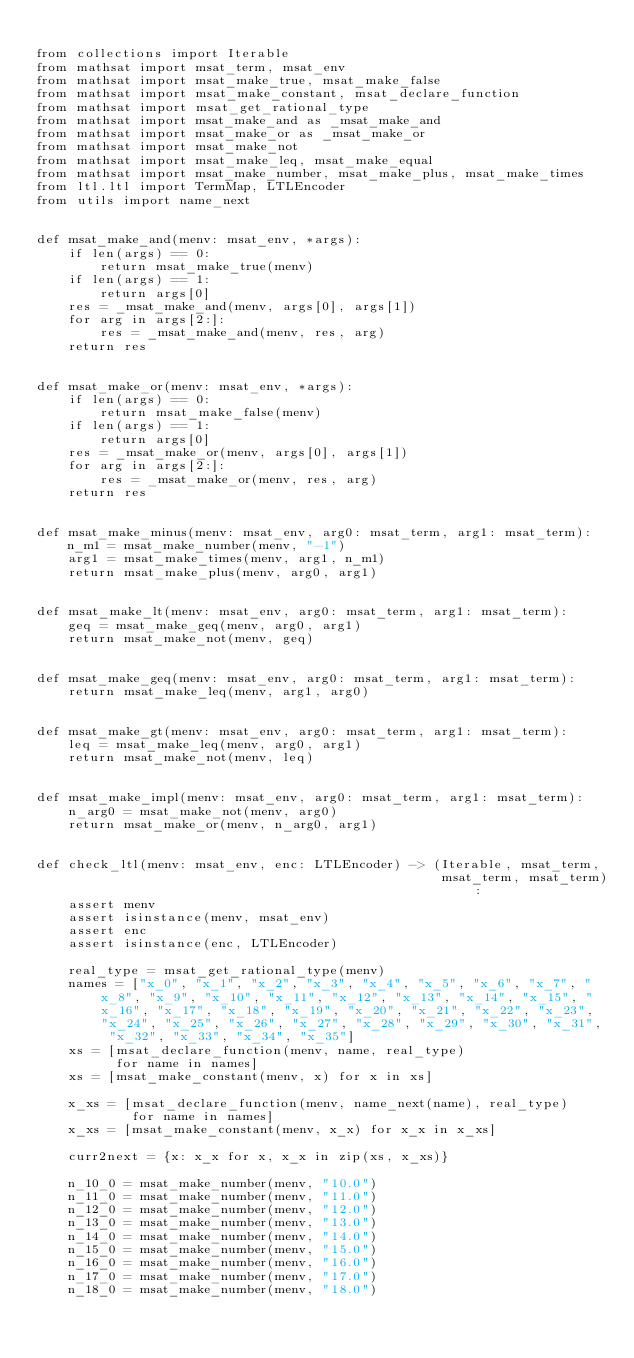Convert code to text. <code><loc_0><loc_0><loc_500><loc_500><_Python_>
from collections import Iterable
from mathsat import msat_term, msat_env
from mathsat import msat_make_true, msat_make_false
from mathsat import msat_make_constant, msat_declare_function
from mathsat import msat_get_rational_type
from mathsat import msat_make_and as _msat_make_and
from mathsat import msat_make_or as _msat_make_or
from mathsat import msat_make_not
from mathsat import msat_make_leq, msat_make_equal
from mathsat import msat_make_number, msat_make_plus, msat_make_times
from ltl.ltl import TermMap, LTLEncoder
from utils import name_next


def msat_make_and(menv: msat_env, *args):
    if len(args) == 0:
        return msat_make_true(menv)
    if len(args) == 1:
        return args[0]
    res = _msat_make_and(menv, args[0], args[1])
    for arg in args[2:]:
        res = _msat_make_and(menv, res, arg)
    return res


def msat_make_or(menv: msat_env, *args):
    if len(args) == 0:
        return msat_make_false(menv)
    if len(args) == 1:
        return args[0]
    res = _msat_make_or(menv, args[0], args[1])
    for arg in args[2:]:
        res = _msat_make_or(menv, res, arg)
    return res


def msat_make_minus(menv: msat_env, arg0: msat_term, arg1: msat_term):
    n_m1 = msat_make_number(menv, "-1")
    arg1 = msat_make_times(menv, arg1, n_m1)
    return msat_make_plus(menv, arg0, arg1)


def msat_make_lt(menv: msat_env, arg0: msat_term, arg1: msat_term):
    geq = msat_make_geq(menv, arg0, arg1)
    return msat_make_not(menv, geq)


def msat_make_geq(menv: msat_env, arg0: msat_term, arg1: msat_term):
    return msat_make_leq(menv, arg1, arg0)


def msat_make_gt(menv: msat_env, arg0: msat_term, arg1: msat_term):
    leq = msat_make_leq(menv, arg0, arg1)
    return msat_make_not(menv, leq)


def msat_make_impl(menv: msat_env, arg0: msat_term, arg1: msat_term):
    n_arg0 = msat_make_not(menv, arg0)
    return msat_make_or(menv, n_arg0, arg1)


def check_ltl(menv: msat_env, enc: LTLEncoder) -> (Iterable, msat_term,
                                                   msat_term, msat_term):
    assert menv
    assert isinstance(menv, msat_env)
    assert enc
    assert isinstance(enc, LTLEncoder)

    real_type = msat_get_rational_type(menv)
    names = ["x_0", "x_1", "x_2", "x_3", "x_4", "x_5", "x_6", "x_7", "x_8", "x_9", "x_10", "x_11", "x_12", "x_13", "x_14", "x_15", "x_16", "x_17", "x_18", "x_19", "x_20", "x_21", "x_22", "x_23", "x_24", "x_25", "x_26", "x_27", "x_28", "x_29", "x_30", "x_31", "x_32", "x_33", "x_34", "x_35"]
    xs = [msat_declare_function(menv, name, real_type)
          for name in names]
    xs = [msat_make_constant(menv, x) for x in xs]

    x_xs = [msat_declare_function(menv, name_next(name), real_type)
            for name in names]
    x_xs = [msat_make_constant(menv, x_x) for x_x in x_xs]

    curr2next = {x: x_x for x, x_x in zip(xs, x_xs)}

    n_10_0 = msat_make_number(menv, "10.0")
    n_11_0 = msat_make_number(menv, "11.0")
    n_12_0 = msat_make_number(menv, "12.0")
    n_13_0 = msat_make_number(menv, "13.0")
    n_14_0 = msat_make_number(menv, "14.0")
    n_15_0 = msat_make_number(menv, "15.0")
    n_16_0 = msat_make_number(menv, "16.0")
    n_17_0 = msat_make_number(menv, "17.0")
    n_18_0 = msat_make_number(menv, "18.0")</code> 